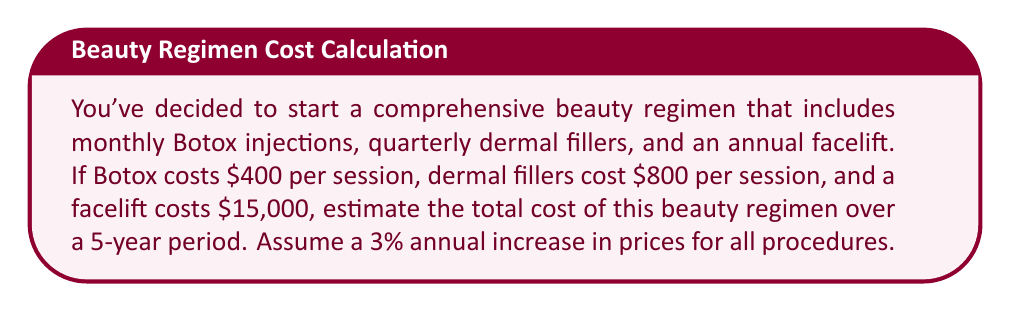What is the answer to this math problem? Let's break this down step-by-step:

1) First, let's calculate the base yearly costs:
   Botox: $400 × 12 months = $4,800/year
   Dermal fillers: $800 × 4 quarters = $3,200/year
   Facelift: $15,000/year

2) Total base yearly cost: $4,800 + $3,200 + $15,000 = $23,000

3) Now, let's account for the 3% annual price increase:
   Year 1: $23,000
   Year 2: $23,000 × 1.03 = $23,690
   Year 3: $23,690 × 1.03 = $24,400.70
   Year 4: $24,400.70 × 1.03 = $25,132.72
   Year 5: $25,132.72 × 1.03 = $25,886.70

4) To get the total cost over 5 years, we sum these amounts:

   $$\sum_{i=1}^{5} 23000 \times (1.03)^{i-1}$$

5) Calculating this sum:
   $23,000 + 23,690 + 24,400.70 + 25,132.72 + 25,886.70 = 122,110.12$

Therefore, the estimated total cost over 5 years is $122,110.12.
Answer: $122,110.12 